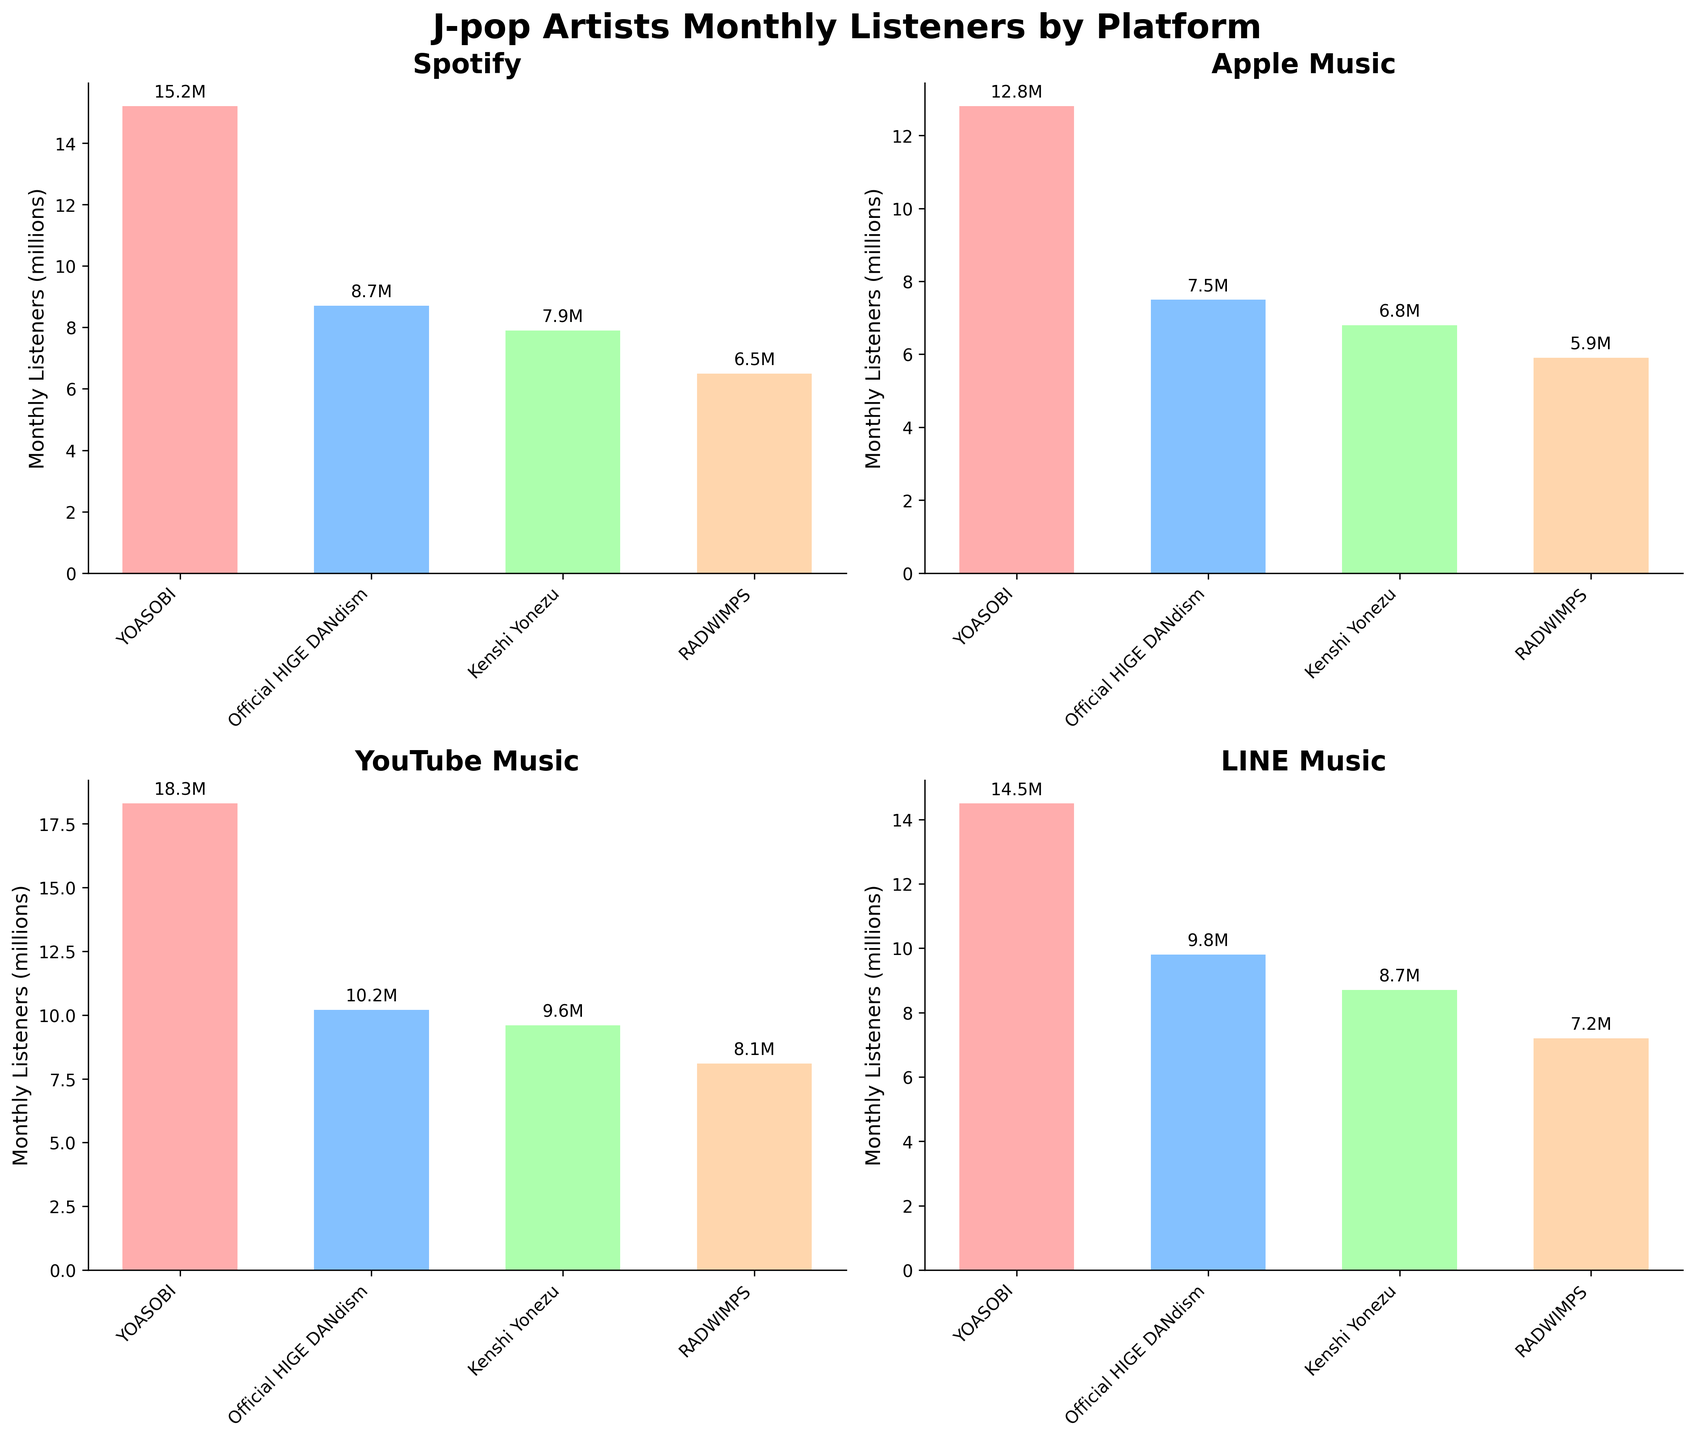What is the title of the figure? The title of the figure is usually displayed at the top and is written in a larger, bold font.
Answer: J-pop Artists Monthly Listeners by Platform Which platform has the highest number of monthly listeners for YOASOBI? Look at the bar heights corresponding to YOASOBI across all platforms and identify the tallest bar.
Answer: YouTube Music What is the difference in monthly listeners between RADWIMPS on Spotify and Apple Music? Find and subtract the monthly listeners for RADWIMPS on Spotify and Apple Music from the respective subplots.
Answer: 0.6 million listeners How many unique artists are shown in the figure? Count the number of unique names across all four subplots.
Answer: 4 Which platform has the lowest total monthly listeners for Official HIGE DANdism and RADWIMPS combined? Sum the monthly listeners for Official HIGE DANdism and RADWIMPS across each platform, and identify the platform with the lowest sum.
Answer: Apple Music Among the artists shown, who has the most consistent number of monthly listeners across all platforms? Compare the bar heights for each artist across all platforms to determine who has the smallest variance.
Answer: YOASOBI Which platform shows the smallest discrepancy in monthly listeners between Kenshi Yonezu and RADWIMPS? Calculate the differences between the monthly listeners for Kenshi Yonezu and RADWIMPS on each platform, and identify the smallest value.
Answer: Line Music On which platform do the combined monthly listeners for all artists exceed 30 million? Sum the monthly listeners for all artists on each platform and identify any platform where the sum exceeds 30 million.
Answer: YouTube Music 